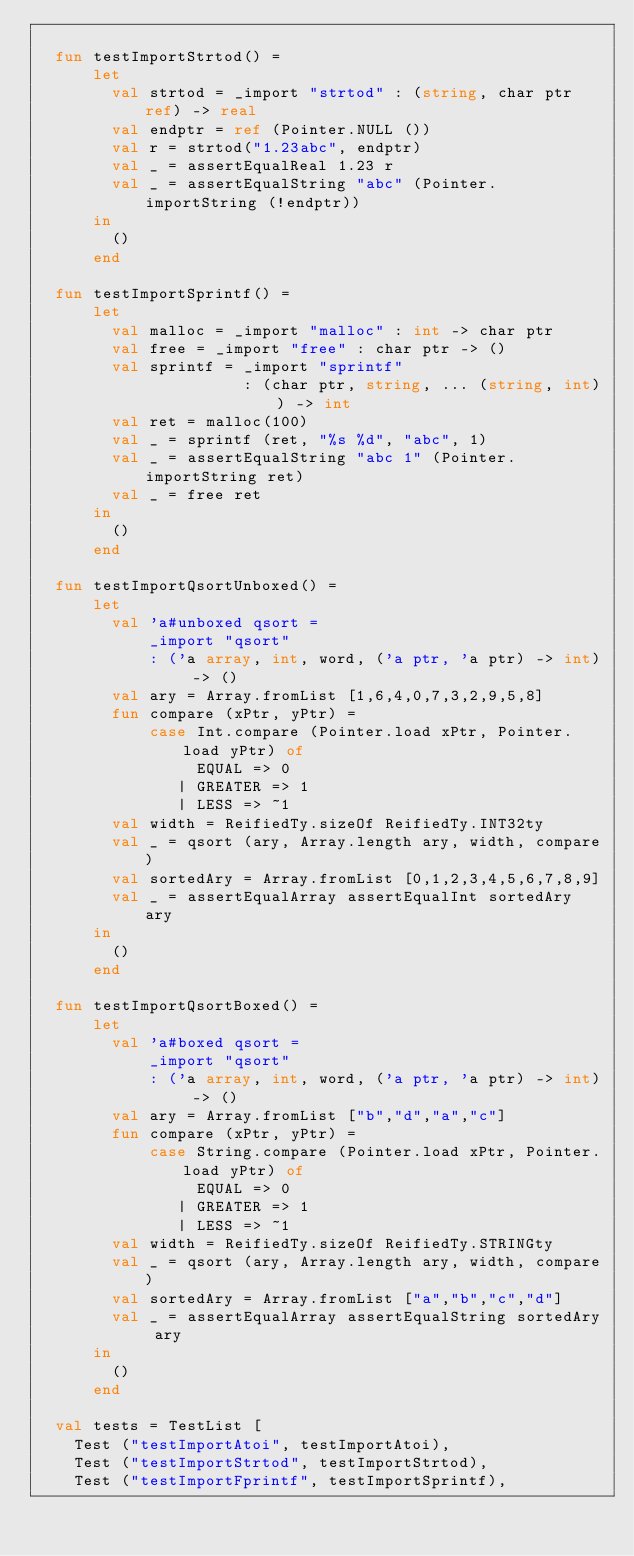<code> <loc_0><loc_0><loc_500><loc_500><_SML_>
  fun testImportStrtod() =
      let
        val strtod = _import "strtod" : (string, char ptr ref) -> real
        val endptr = ref (Pointer.NULL ())
        val r = strtod("1.23abc", endptr)
        val _ = assertEqualReal 1.23 r
        val _ = assertEqualString "abc" (Pointer.importString (!endptr))
      in
        ()
      end

  fun testImportSprintf() =
      let
        val malloc = _import "malloc" : int -> char ptr
        val free = _import "free" : char ptr -> ()
        val sprintf = _import "sprintf" 
                      : (char ptr, string, ... (string, int)) -> int 
        val ret = malloc(100)
        val _ = sprintf (ret, "%s %d", "abc", 1)
        val _ = assertEqualString "abc 1" (Pointer.importString ret)
        val _ = free ret
      in
        ()
      end

  fun testImportQsortUnboxed() =
      let
        val 'a#unboxed qsort =
            _import "qsort" 
            : ('a array, int, word, ('a ptr, 'a ptr) -> int) -> ()
        val ary = Array.fromList [1,6,4,0,7,3,2,9,5,8]
        fun compare (xPtr, yPtr) = 
            case Int.compare (Pointer.load xPtr, Pointer.load yPtr) of
                 EQUAL => 0
               | GREATER => 1
               | LESS => ~1
        val width = ReifiedTy.sizeOf ReifiedTy.INT32ty
        val _ = qsort (ary, Array.length ary, width, compare)
        val sortedAry = Array.fromList [0,1,2,3,4,5,6,7,8,9]
        val _ = assertEqualArray assertEqualInt sortedAry ary
      in
        ()
      end

  fun testImportQsortBoxed() =
      let
        val 'a#boxed qsort =
            _import "qsort" 
            : ('a array, int, word, ('a ptr, 'a ptr) -> int) -> ()
        val ary = Array.fromList ["b","d","a","c"]
        fun compare (xPtr, yPtr) = 
            case String.compare (Pointer.load xPtr, Pointer.load yPtr) of
                 EQUAL => 0
               | GREATER => 1
               | LESS => ~1
        val width = ReifiedTy.sizeOf ReifiedTy.STRINGty
        val _ = qsort (ary, Array.length ary, width, compare)
        val sortedAry = Array.fromList ["a","b","c","d"]
        val _ = assertEqualArray assertEqualString sortedAry ary
      in
        ()
      end

  val tests = TestList [
    Test ("testImportAtoi", testImportAtoi),
    Test ("testImportStrtod", testImportStrtod),
    Test ("testImportFprintf", testImportSprintf),</code> 